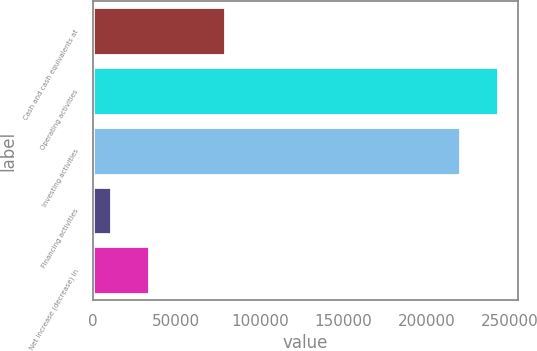Convert chart. <chart><loc_0><loc_0><loc_500><loc_500><bar_chart><fcel>Cash and cash equivalents at<fcel>Operating activities<fcel>Investing activities<fcel>Financing activities<fcel>Net increase (decrease) in<nl><fcel>79276.2<fcel>242577<fcel>219783<fcel>10893<fcel>33687.4<nl></chart> 